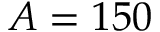Convert formula to latex. <formula><loc_0><loc_0><loc_500><loc_500>A = 1 5 0</formula> 